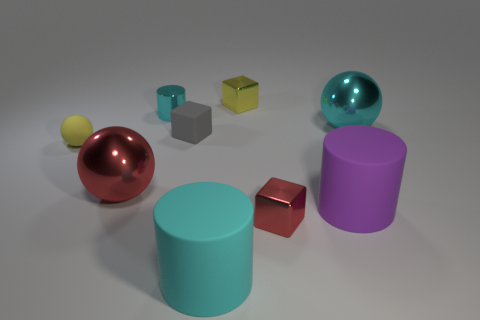Add 1 big purple metal cylinders. How many objects exist? 10 Subtract all cylinders. How many objects are left? 6 Subtract 1 cyan cylinders. How many objects are left? 8 Subtract all tiny red blocks. Subtract all big matte things. How many objects are left? 6 Add 1 tiny gray matte blocks. How many tiny gray matte blocks are left? 2 Add 3 big cyan objects. How many big cyan objects exist? 5 